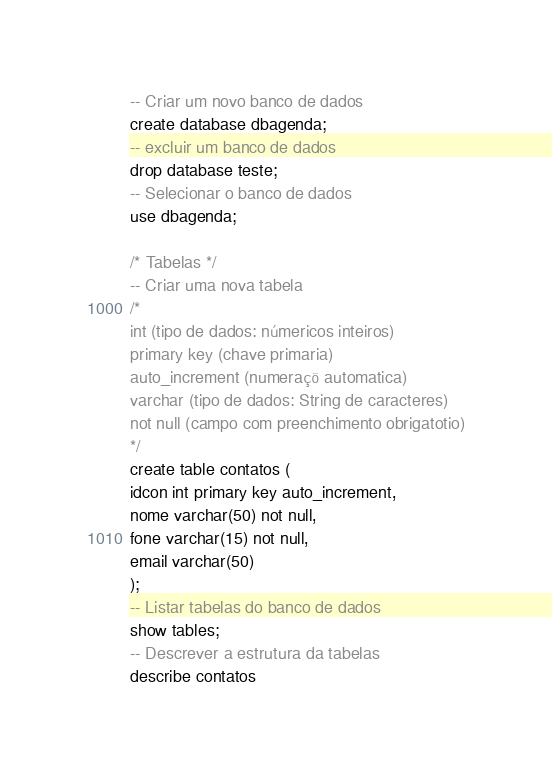<code> <loc_0><loc_0><loc_500><loc_500><_SQL_>-- Criar um novo banco de dados
create database dbagenda;
-- excluir um banco de dados 
drop database teste;
-- Selecionar o banco de dados
use dbagenda;

/* Tabelas */
-- Criar uma nova tabela
/*
int (tipo de dados: númericos inteiros)
primary key (chave primaria)
auto_increment (numeraçõ automatica)
varchar (tipo de dados: String de caracteres)
not null (campo com preenchimento obrigatotio)
*/
create table contatos (
idcon int primary key auto_increment,
nome varchar(50) not null,
fone varchar(15) not null,
email varchar(50)
);
-- Listar tabelas do banco de dados
show tables;
-- Descrever a estrutura da tabelas
describe contatos

</code> 